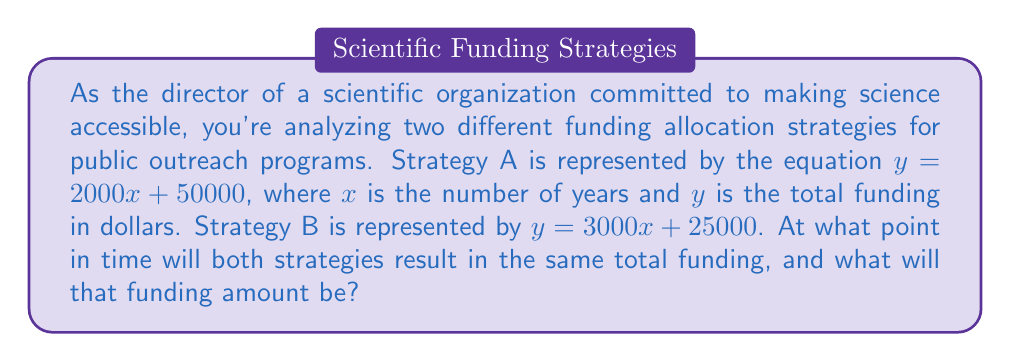Can you answer this question? To solve this problem, we need to find the intersection point of the two linear equations. This is where the funding amounts will be equal for both strategies.

Step 1: Set up the equation
Since we're looking for the point where both strategies have the same funding, we can set the equations equal to each other:
$2000x + 50000 = 3000x + 25000$

Step 2: Solve for x
Subtract 2000x from both sides:
$50000 = 1000x + 25000$

Subtract 25000 from both sides:
$25000 = 1000x$

Divide both sides by 1000:
$25 = x$

Step 3: Find the y-coordinate (funding amount)
We can use either equation to find y. Let's use Strategy A:
$y = 2000(25) + 50000$
$y = 50000 + 50000 = 100000$

Therefore, the strategies will result in the same funding after 25 years, with a total funding amount of $100,000.
Answer: (25, 100000) 